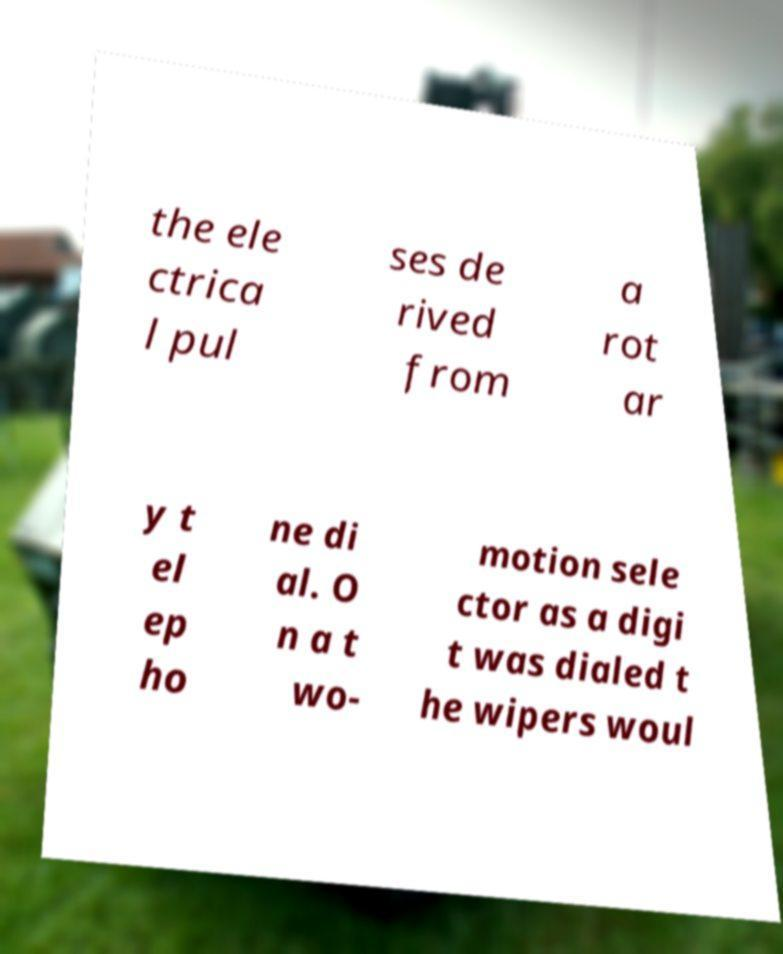Can you read and provide the text displayed in the image?This photo seems to have some interesting text. Can you extract and type it out for me? the ele ctrica l pul ses de rived from a rot ar y t el ep ho ne di al. O n a t wo- motion sele ctor as a digi t was dialed t he wipers woul 